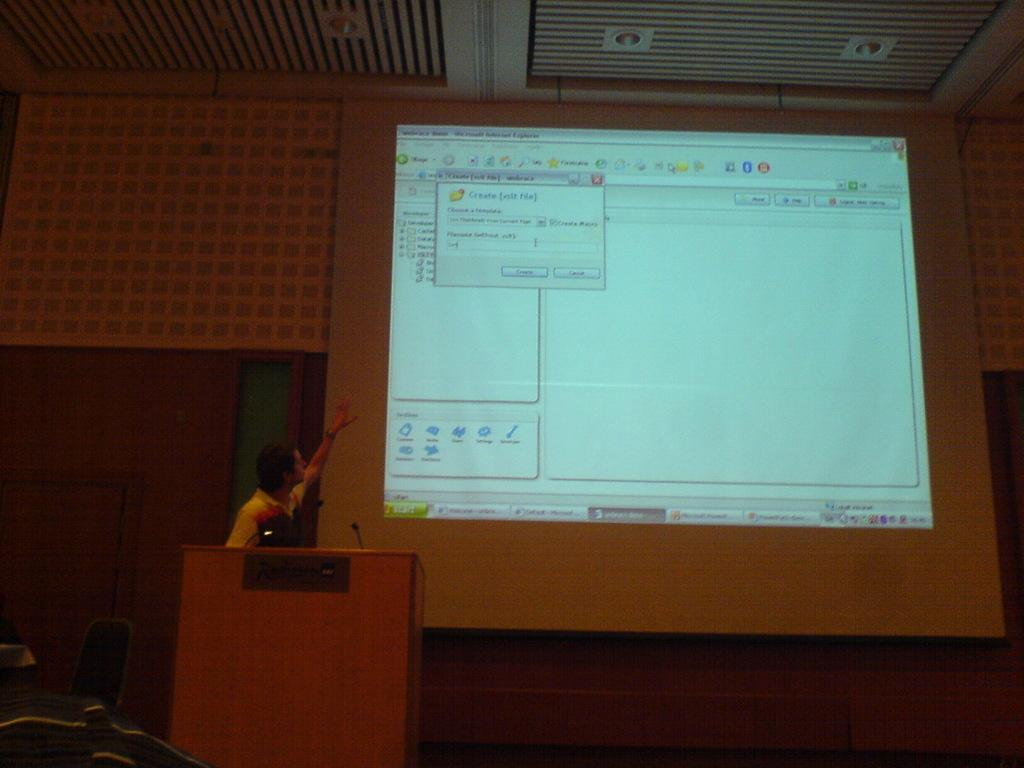<image>
Create a compact narrative representing the image presented. a huge projection screen that is lit up with a tab that says 'create' on it 